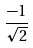<formula> <loc_0><loc_0><loc_500><loc_500>\frac { - 1 } { \sqrt { 2 } }</formula> 